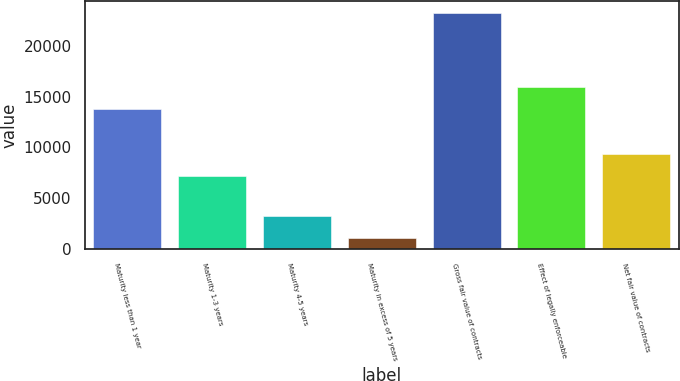Convert chart to OTSL. <chart><loc_0><loc_0><loc_500><loc_500><bar_chart><fcel>Maturity less than 1 year<fcel>Maturity 1-3 years<fcel>Maturity 4-5 years<fcel>Maturity in excess of 5 years<fcel>Gross fair value of contracts<fcel>Effect of legally enforceable<fcel>Net fair value of contracts<nl><fcel>13750<fcel>7155<fcel>3302.9<fcel>1091<fcel>23210<fcel>15961.9<fcel>9366.9<nl></chart> 